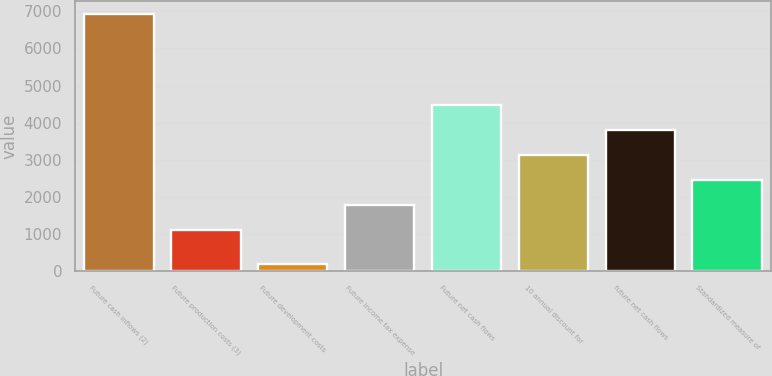Convert chart to OTSL. <chart><loc_0><loc_0><loc_500><loc_500><bar_chart><fcel>Future cash inflows (2)<fcel>Future production costs (3)<fcel>Future development costs<fcel>Future income tax expense<fcel>Future net cash flows<fcel>10 annual discount for<fcel>future net cash flows<fcel>Standardized measure of<nl><fcel>6935<fcel>1112<fcel>202<fcel>1785.3<fcel>4478.5<fcel>3131.9<fcel>3805.2<fcel>2458.6<nl></chart> 